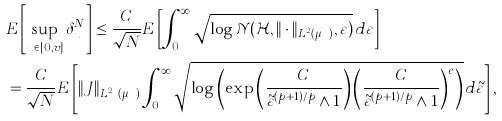<formula> <loc_0><loc_0><loc_500><loc_500>& E \left [ \sup _ { u \in [ 0 , v ] } \delta _ { u } ^ { N } \right ] \leq \frac { C } { \sqrt { N } } E \left [ \int _ { 0 } ^ { \infty } \sqrt { \log \mathcal { N } ( \mathcal { H } , \| \cdot \| _ { L ^ { 2 } ( \mu _ { N } ) } , \varepsilon ) } \, d \varepsilon \right ] \\ & = \frac { C } { \sqrt { N } } E \left [ \| J \| _ { L ^ { 2 p } ( \mu _ { N } ) } \int _ { 0 } ^ { \infty } \sqrt { \log \left ( \exp \left ( \frac { C } { \tilde { \varepsilon } ^ { ( p + 1 ) / p } \wedge 1 } \right ) \left ( \frac { C } { \tilde { \varepsilon } ^ { ( p + 1 ) / p } \wedge 1 } \right ) ^ { e } \right ) } \, d \tilde { \varepsilon } \right ] ,</formula> 